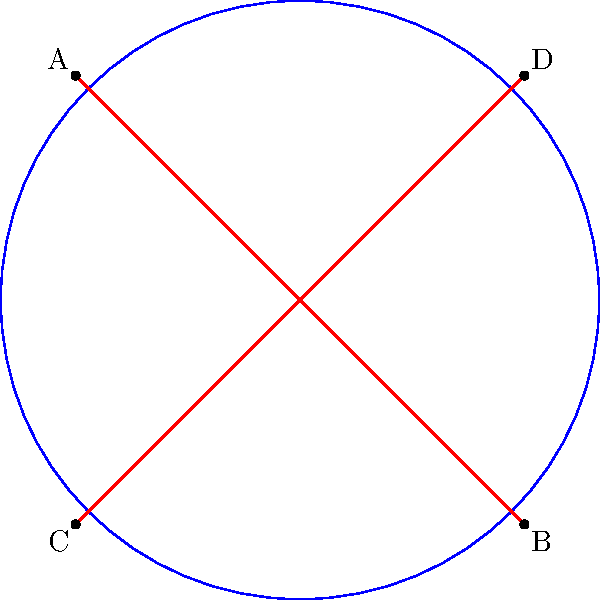As a business traveler navigating international regulations, you encounter a diagram illustrating parallel lines in elliptic geometry. In this model, what is the key characteristic of these "parallel" lines that differs from Euclidean geometry? To understand the behavior of parallel lines in elliptic geometry, let's follow these steps:

1. In Euclidean geometry, parallel lines never intersect and maintain a constant distance from each other.

2. The diagram shows a circle, which represents a model of elliptic geometry (specifically, the Riemann sphere model).

3. The red lines AB and CD are great circles on this sphere, which are the equivalent of "straight lines" in elliptic geometry.

4. Notice that these lines intersect at two points: one visible in the diagram (near the top-right and bottom-left) and one on the opposite side of the sphere (not visible in this 2D representation).

5. In elliptic geometry, all "straight lines" (great circles) intersect at exactly two antipodal points.

6. This means that in elliptic geometry, there are no lines that remain a constant distance apart and never intersect.

7. Therefore, the concept of parallel lines as we know it in Euclidean geometry does not exist in elliptic geometry.

The key characteristic that differs from Euclidean geometry is that these "parallel" lines in elliptic geometry always intersect at two points, whereas in Euclidean geometry, parallel lines never intersect.
Answer: Intersect at two points 